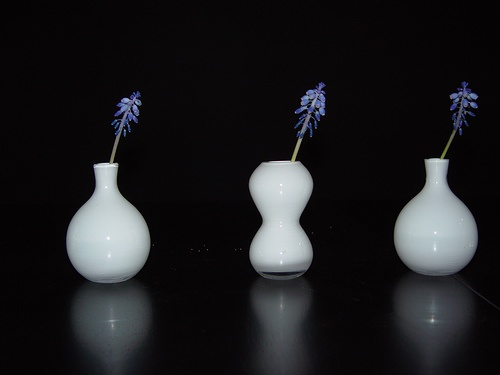Describe the objects in this image and their specific colors. I can see vase in black, lightgray, darkgray, and gray tones, vase in black, darkgray, lightgray, and gray tones, and vase in black, lightgray, darkgray, and gray tones in this image. 